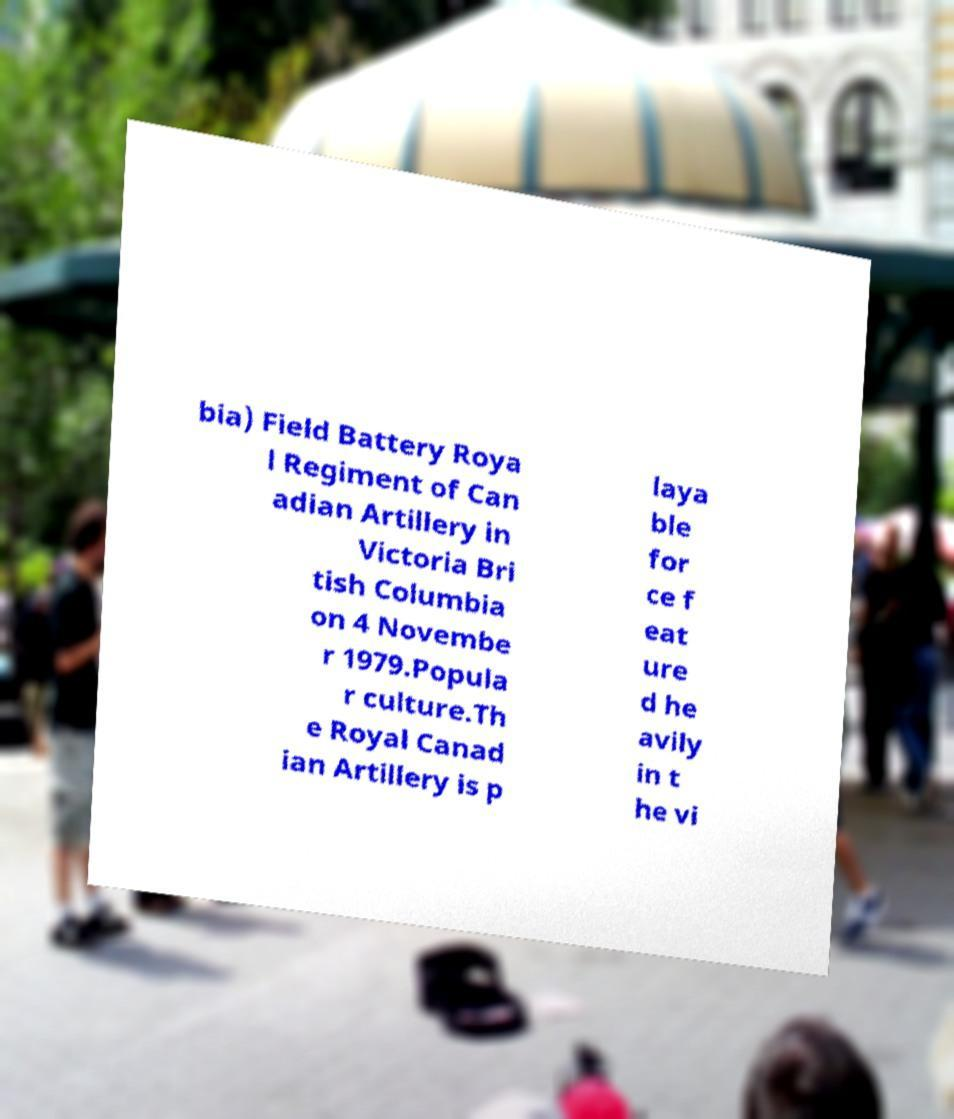Can you read and provide the text displayed in the image?This photo seems to have some interesting text. Can you extract and type it out for me? bia) Field Battery Roya l Regiment of Can adian Artillery in Victoria Bri tish Columbia on 4 Novembe r 1979.Popula r culture.Th e Royal Canad ian Artillery is p laya ble for ce f eat ure d he avily in t he vi 